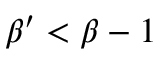Convert formula to latex. <formula><loc_0><loc_0><loc_500><loc_500>\beta ^ { \prime } < \beta - 1</formula> 